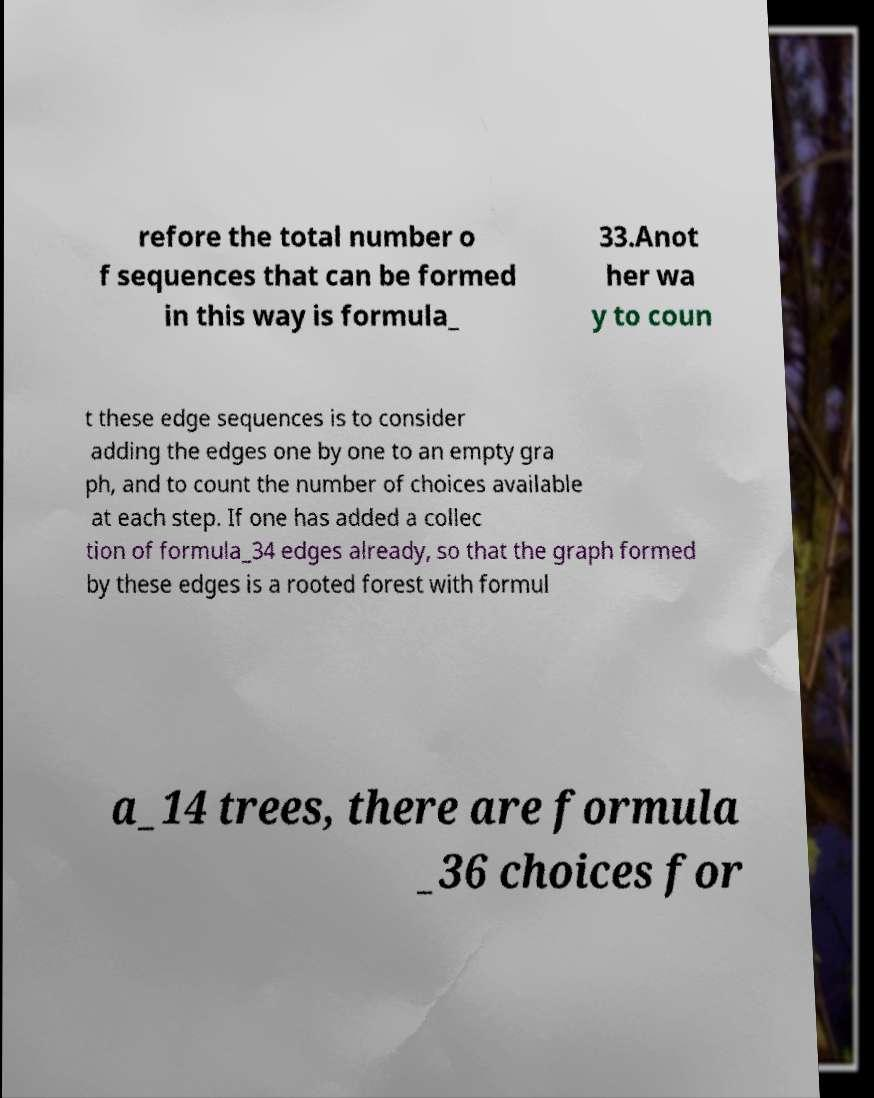Can you read and provide the text displayed in the image?This photo seems to have some interesting text. Can you extract and type it out for me? refore the total number o f sequences that can be formed in this way is formula_ 33.Anot her wa y to coun t these edge sequences is to consider adding the edges one by one to an empty gra ph, and to count the number of choices available at each step. If one has added a collec tion of formula_34 edges already, so that the graph formed by these edges is a rooted forest with formul a_14 trees, there are formula _36 choices for 